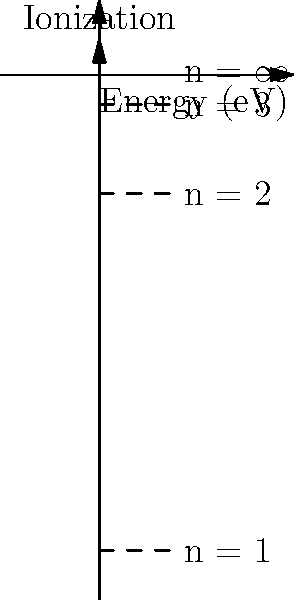Given the energy level diagram for a hydrogen atom, what is the energy required for an electron to transition from the ground state (n = 1) to the first excited state (n = 2)? Express your answer in electron volts (eV). To solve this problem, we need to follow these steps:

1. Identify the energy levels for n = 1 and n = 2 from the diagram:
   - n = 1 (ground state): E₁ = -13.6 eV
   - n = 2 (first excited state): E₂ = -3.4 eV

2. Calculate the energy difference between these two states:
   ΔE = E₂ - E₁
   ΔE = (-3.4 eV) - (-13.6 eV)
   ΔE = -3.4 eV + 13.6 eV
   ΔE = 10.2 eV

3. The positive value indicates that energy must be absorbed by the electron to make this transition.

Therefore, the energy required for an electron to transition from the ground state to the first excited state in a hydrogen atom is 10.2 eV.
Answer: 10.2 eV 